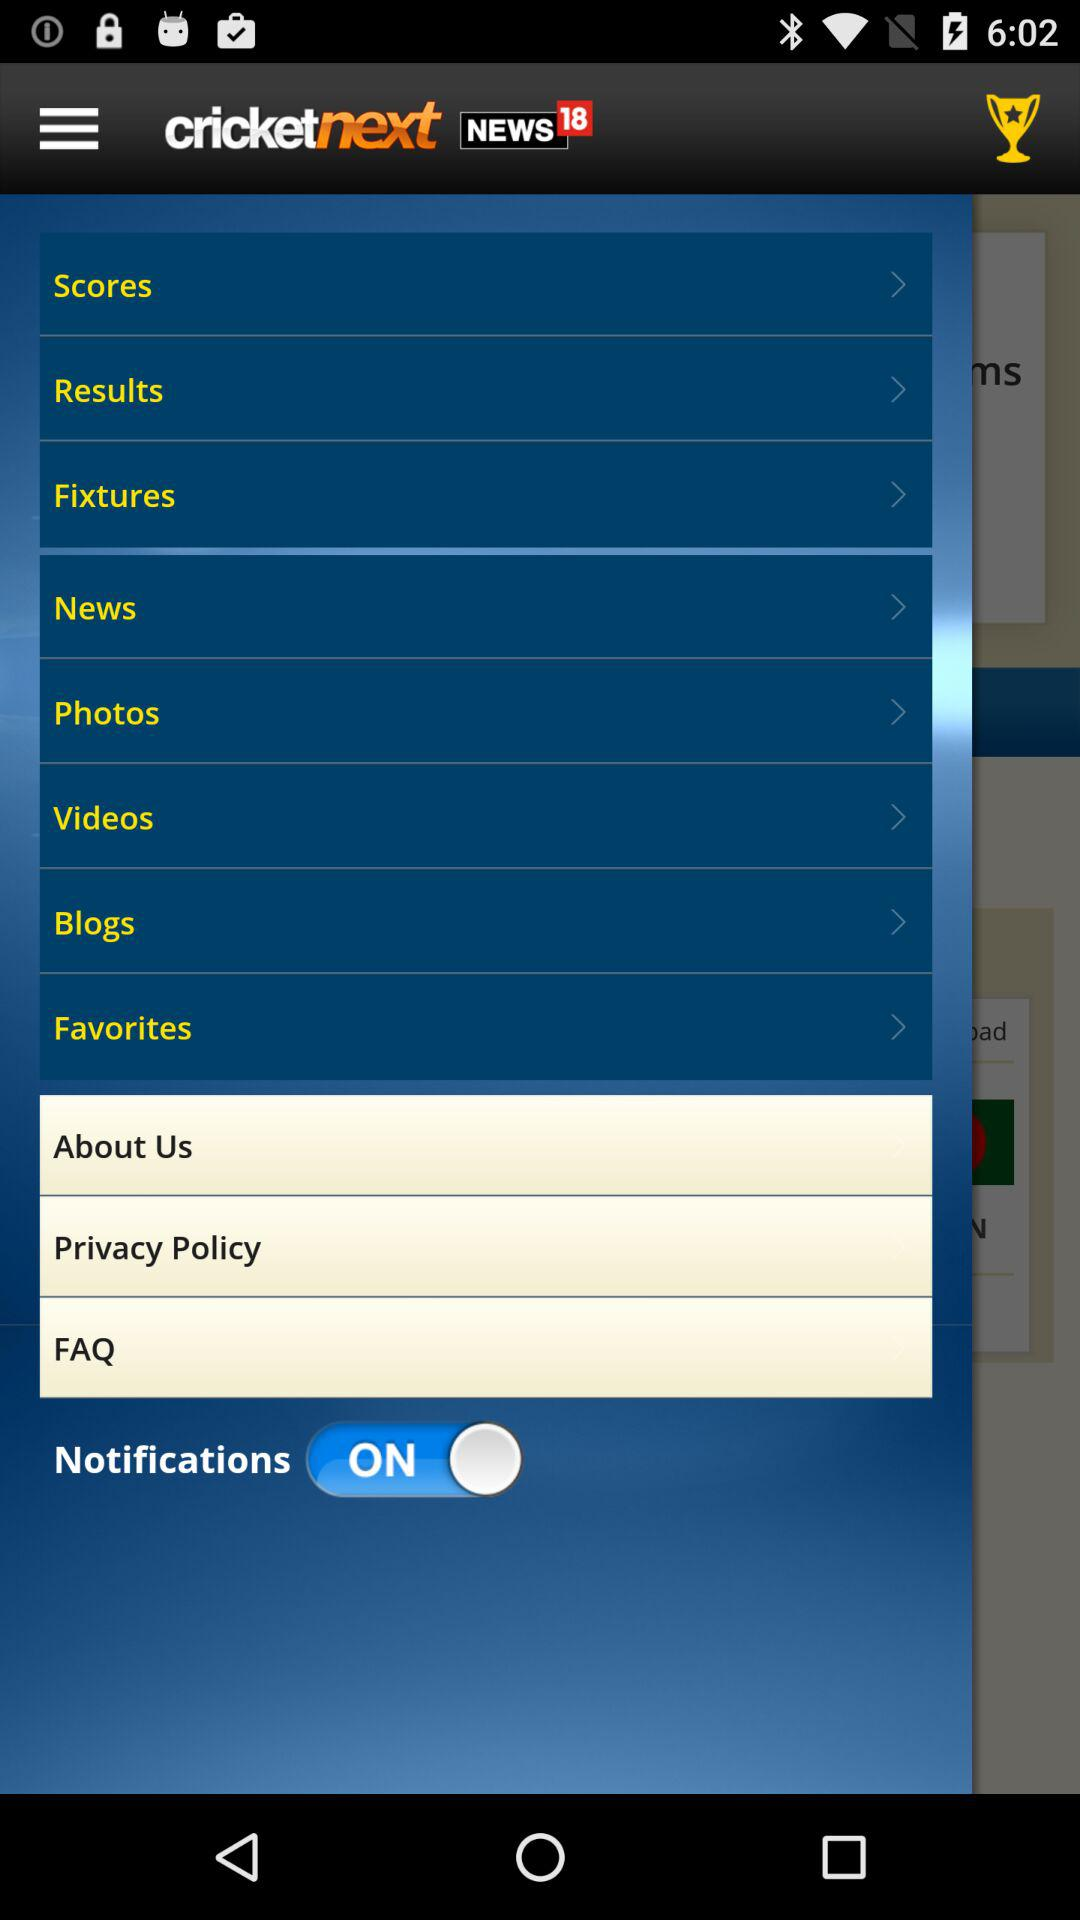What is the status of "Notifications"? The status is "on". 